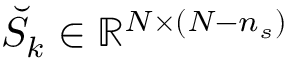Convert formula to latex. <formula><loc_0><loc_0><loc_500><loc_500>\breve { S } _ { k } \in \mathbb { R } ^ { N \times ( N - n _ { s } ) }</formula> 